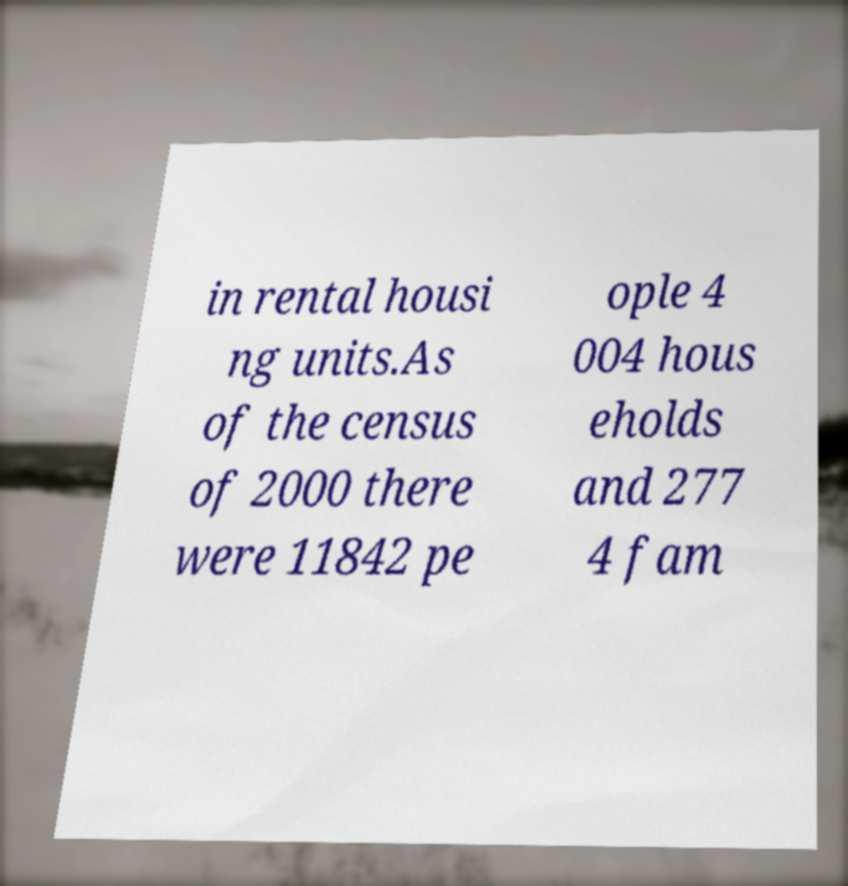Could you assist in decoding the text presented in this image and type it out clearly? in rental housi ng units.As of the census of 2000 there were 11842 pe ople 4 004 hous eholds and 277 4 fam 